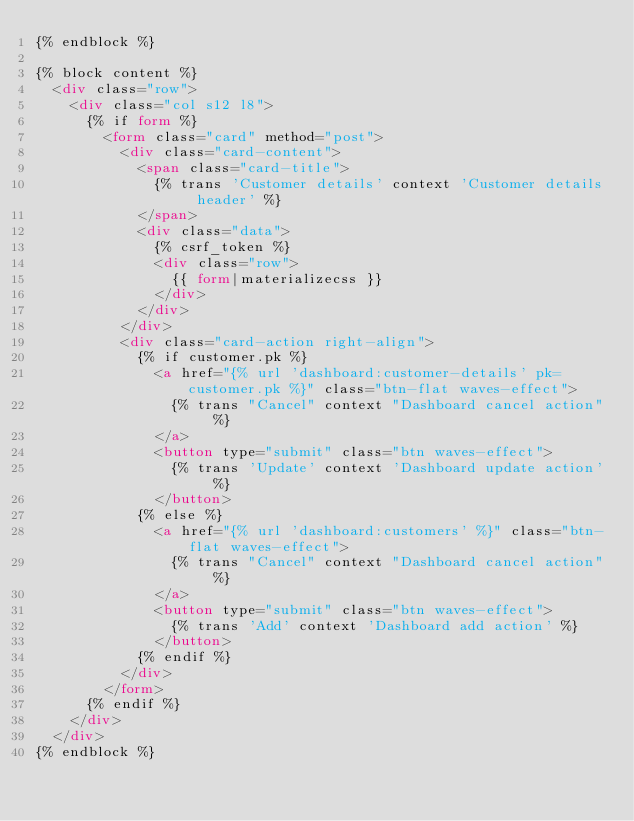<code> <loc_0><loc_0><loc_500><loc_500><_HTML_>{% endblock %}

{% block content %}
  <div class="row">
    <div class="col s12 l8">
      {% if form %}
        <form class="card" method="post">
          <div class="card-content">
            <span class="card-title">
              {% trans 'Customer details' context 'Customer details header' %}
            </span>
            <div class="data">
              {% csrf_token %}
              <div class="row">
                {{ form|materializecss }}
              </div>
            </div>
          </div>
          <div class="card-action right-align">
            {% if customer.pk %}
              <a href="{% url 'dashboard:customer-details' pk=customer.pk %}" class="btn-flat waves-effect">
                {% trans "Cancel" context "Dashboard cancel action" %}
              </a>
              <button type="submit" class="btn waves-effect">
                {% trans 'Update' context 'Dashboard update action' %}
              </button>
            {% else %}
              <a href="{% url 'dashboard:customers' %}" class="btn-flat waves-effect">
                {% trans "Cancel" context "Dashboard cancel action" %}
              </a>
              <button type="submit" class="btn waves-effect">
                {% trans 'Add' context 'Dashboard add action' %}
              </button>
            {% endif %}
          </div>
        </form>
      {% endif %}
    </div>
  </div>
{% endblock %}
</code> 